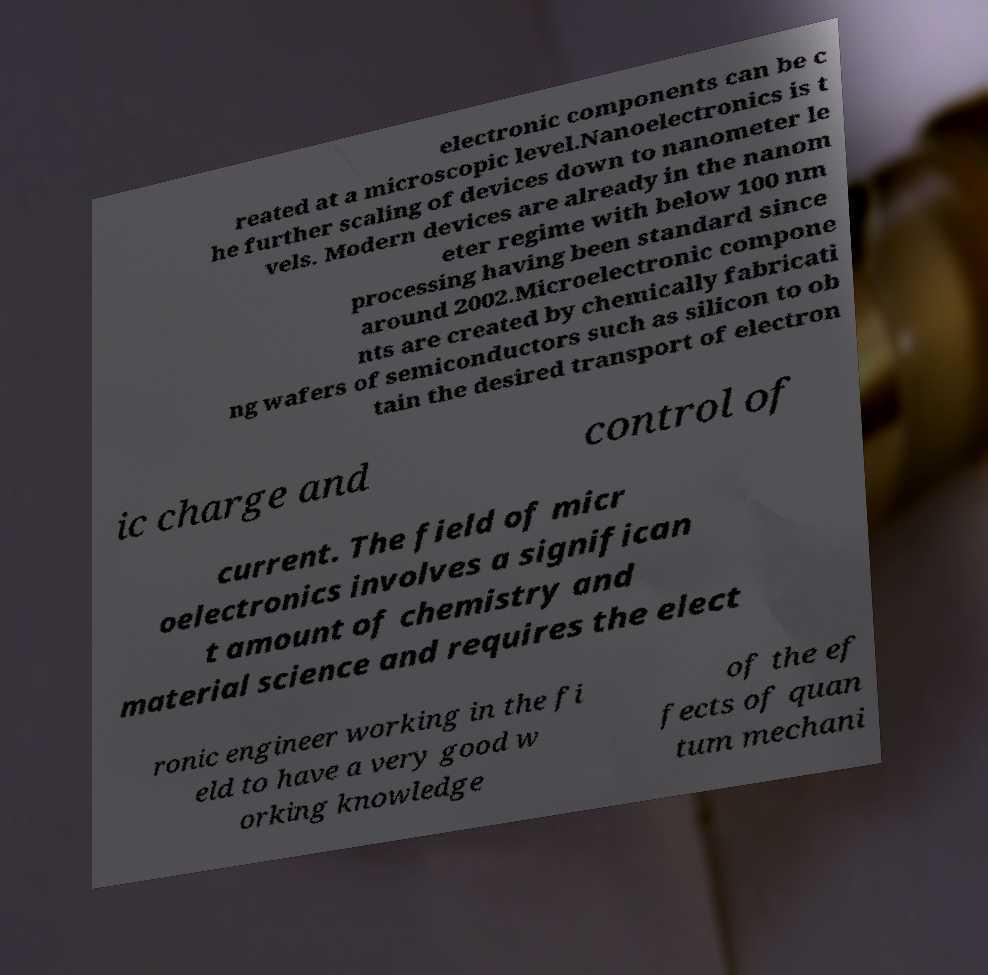I need the written content from this picture converted into text. Can you do that? electronic components can be c reated at a microscopic level.Nanoelectronics is t he further scaling of devices down to nanometer le vels. Modern devices are already in the nanom eter regime with below 100 nm processing having been standard since around 2002.Microelectronic compone nts are created by chemically fabricati ng wafers of semiconductors such as silicon to ob tain the desired transport of electron ic charge and control of current. The field of micr oelectronics involves a significan t amount of chemistry and material science and requires the elect ronic engineer working in the fi eld to have a very good w orking knowledge of the ef fects of quan tum mechani 